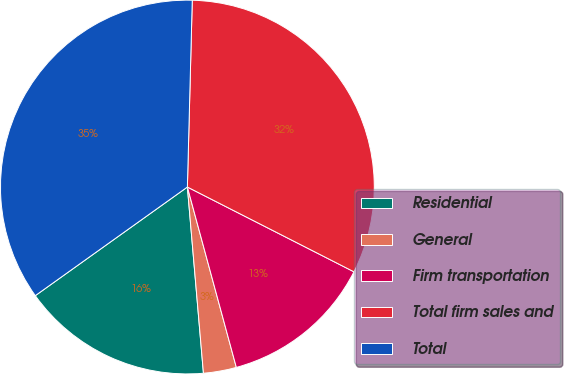Convert chart to OTSL. <chart><loc_0><loc_0><loc_500><loc_500><pie_chart><fcel>Residential<fcel>General<fcel>Firm transportation<fcel>Total firm sales and<fcel>Total<nl><fcel>16.5%<fcel>2.85%<fcel>13.29%<fcel>32.08%<fcel>35.29%<nl></chart> 